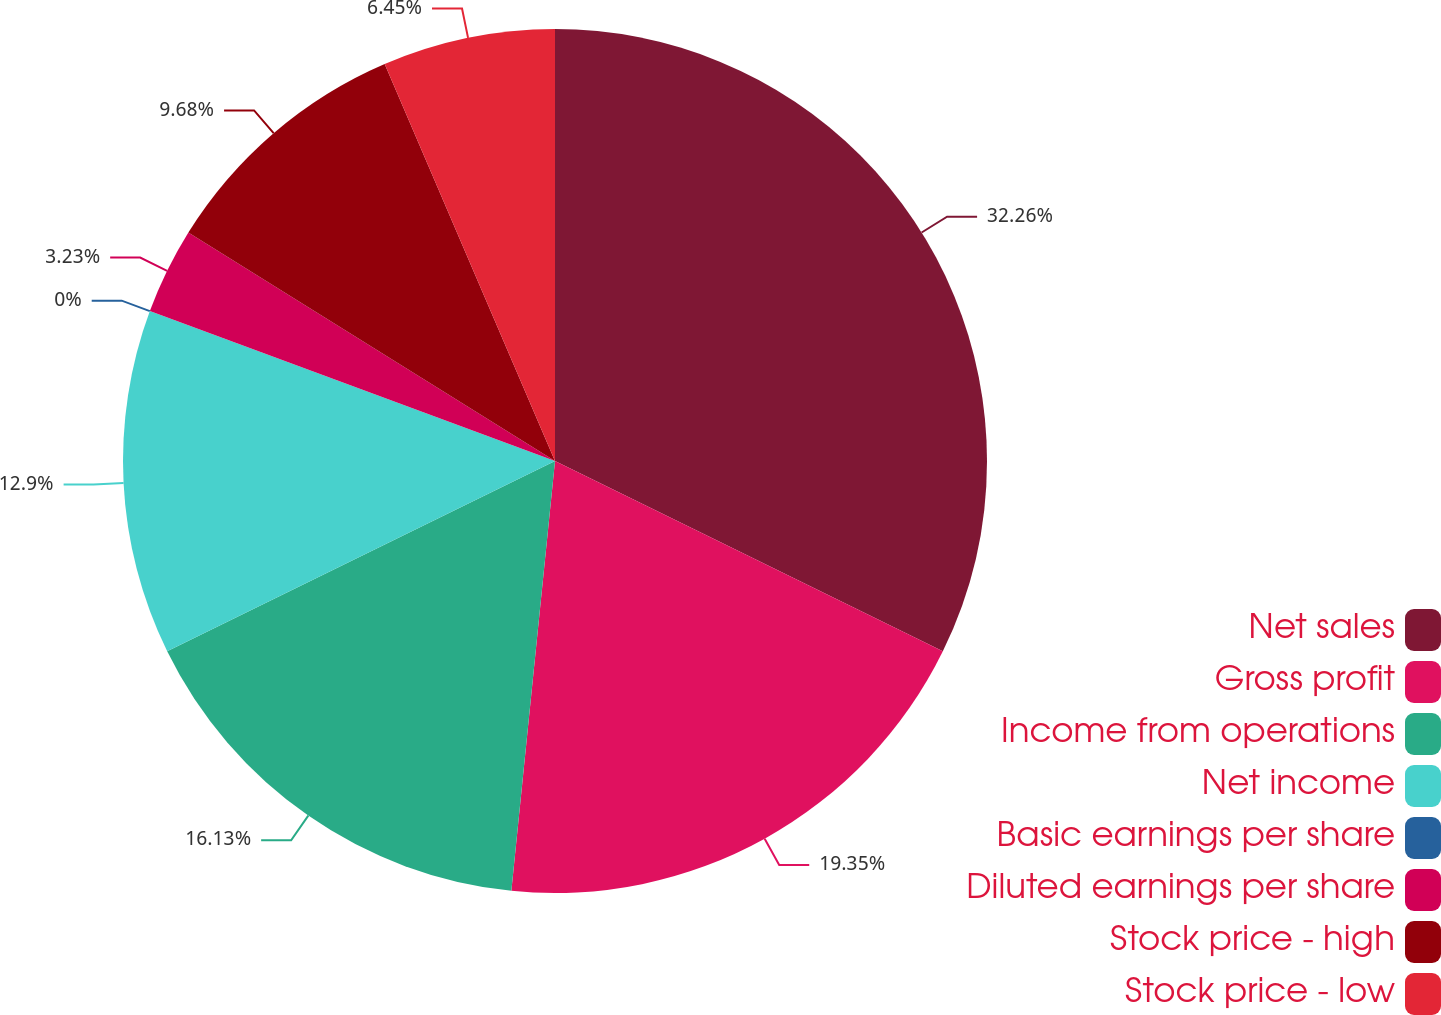Convert chart to OTSL. <chart><loc_0><loc_0><loc_500><loc_500><pie_chart><fcel>Net sales<fcel>Gross profit<fcel>Income from operations<fcel>Net income<fcel>Basic earnings per share<fcel>Diluted earnings per share<fcel>Stock price - high<fcel>Stock price - low<nl><fcel>32.26%<fcel>19.35%<fcel>16.13%<fcel>12.9%<fcel>0.0%<fcel>3.23%<fcel>9.68%<fcel>6.45%<nl></chart> 